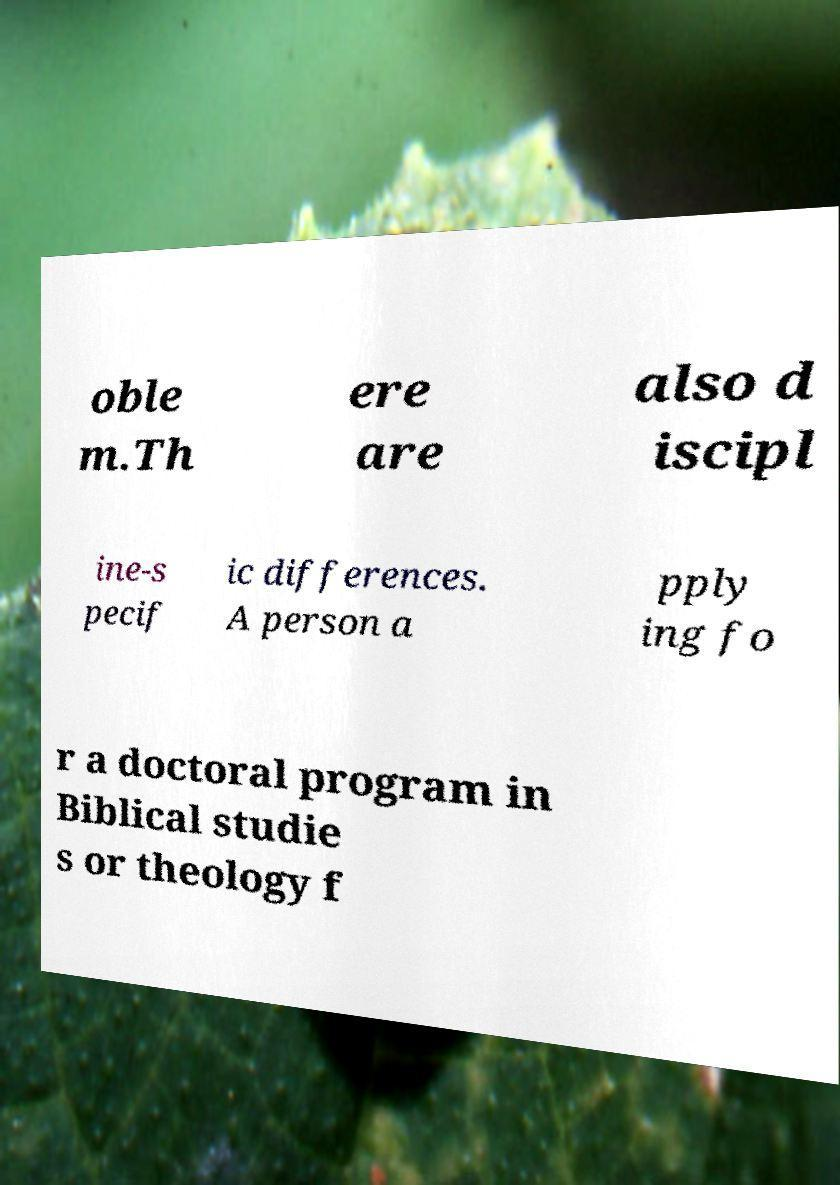For documentation purposes, I need the text within this image transcribed. Could you provide that? oble m.Th ere are also d iscipl ine-s pecif ic differences. A person a pply ing fo r a doctoral program in Biblical studie s or theology f 